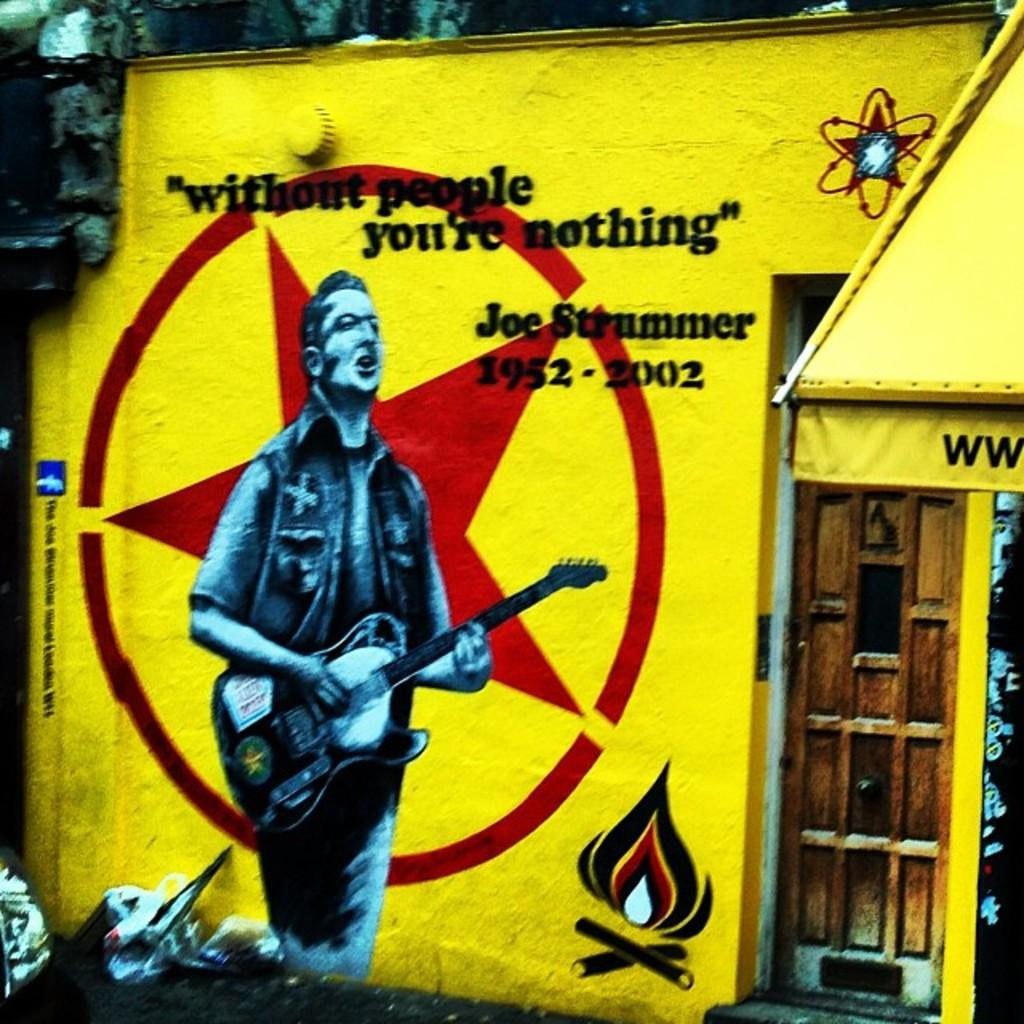<image>
Give a short and clear explanation of the subsequent image. A man with a guitar is labeled as Joe Strummer. 